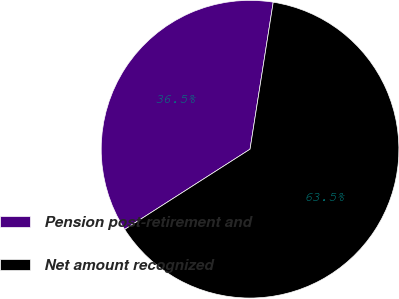Convert chart to OTSL. <chart><loc_0><loc_0><loc_500><loc_500><pie_chart><fcel>Pension post-retirement and<fcel>Net amount recognized<nl><fcel>36.55%<fcel>63.45%<nl></chart> 